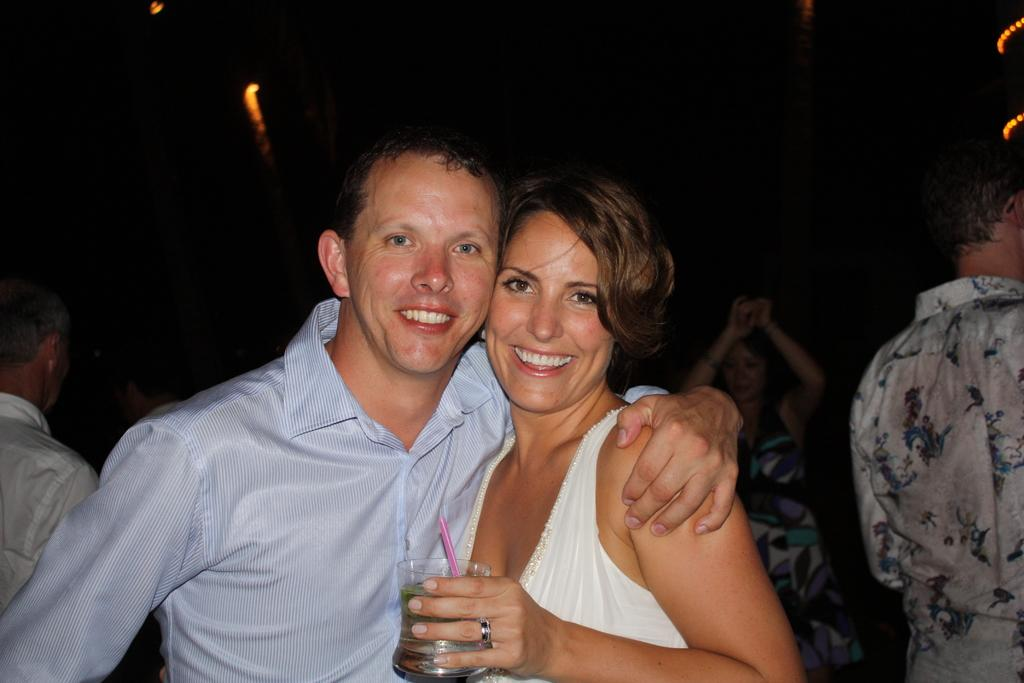Who are the two people in the middle of the image? There is a man and a woman in the middle of the image. What expression do the man and woman have? The man and woman are smiling. What can be seen in the background of the image? There are people in the background of the image. What is visible at the top of the image? There are lights visible at the top of the image. Can you tell me how many frogs are sitting on the string in the image? There are no frogs or strings present in the image. What type of town is visible in the background of the image? There is no town visible in the image; it only shows the man, woman, and people in the background. 